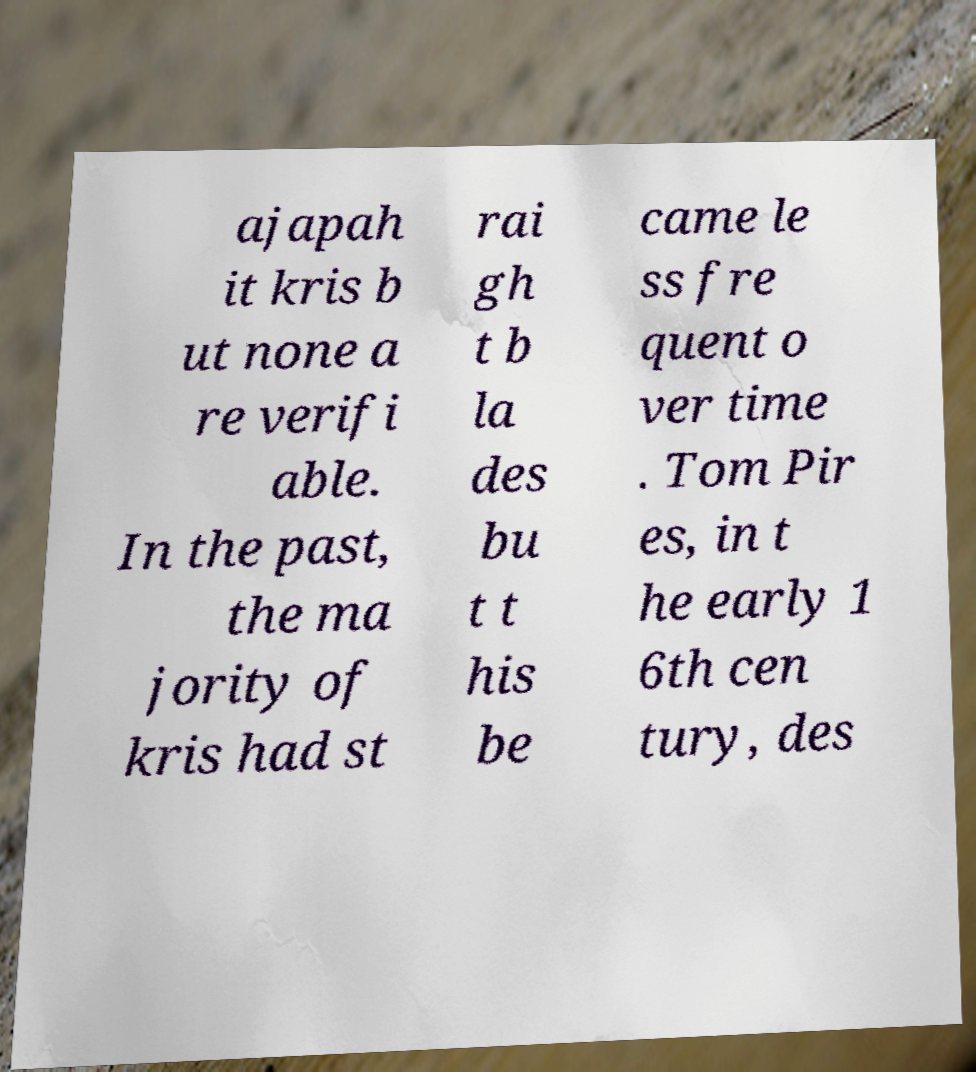Can you read and provide the text displayed in the image?This photo seems to have some interesting text. Can you extract and type it out for me? ajapah it kris b ut none a re verifi able. In the past, the ma jority of kris had st rai gh t b la des bu t t his be came le ss fre quent o ver time . Tom Pir es, in t he early 1 6th cen tury, des 